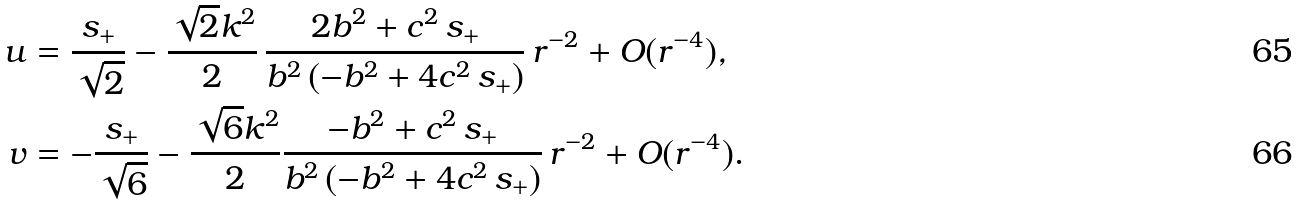Convert formula to latex. <formula><loc_0><loc_0><loc_500><loc_500>u & = \frac { s _ { + } } { \sqrt { 2 } } - \frac { \sqrt { 2 } k ^ { 2 } } { 2 } \, \frac { 2 b ^ { 2 } + c ^ { 2 } \, s _ { + } } { b ^ { 2 } \, ( - b ^ { 2 } + 4 c ^ { 2 } \, s _ { + } ) } \, r ^ { - 2 } + O ( r ^ { - 4 } ) , \\ v & = - \frac { s _ { + } } { \sqrt { 6 } } - \frac { \sqrt { 6 } k ^ { 2 } } { 2 } \frac { - b ^ { 2 } + c ^ { 2 } \, s _ { + } } { b ^ { 2 } \, ( - b ^ { 2 } + 4 c ^ { 2 } \, s _ { + } ) } \, r ^ { - 2 } + O ( r ^ { - 4 } ) .</formula> 